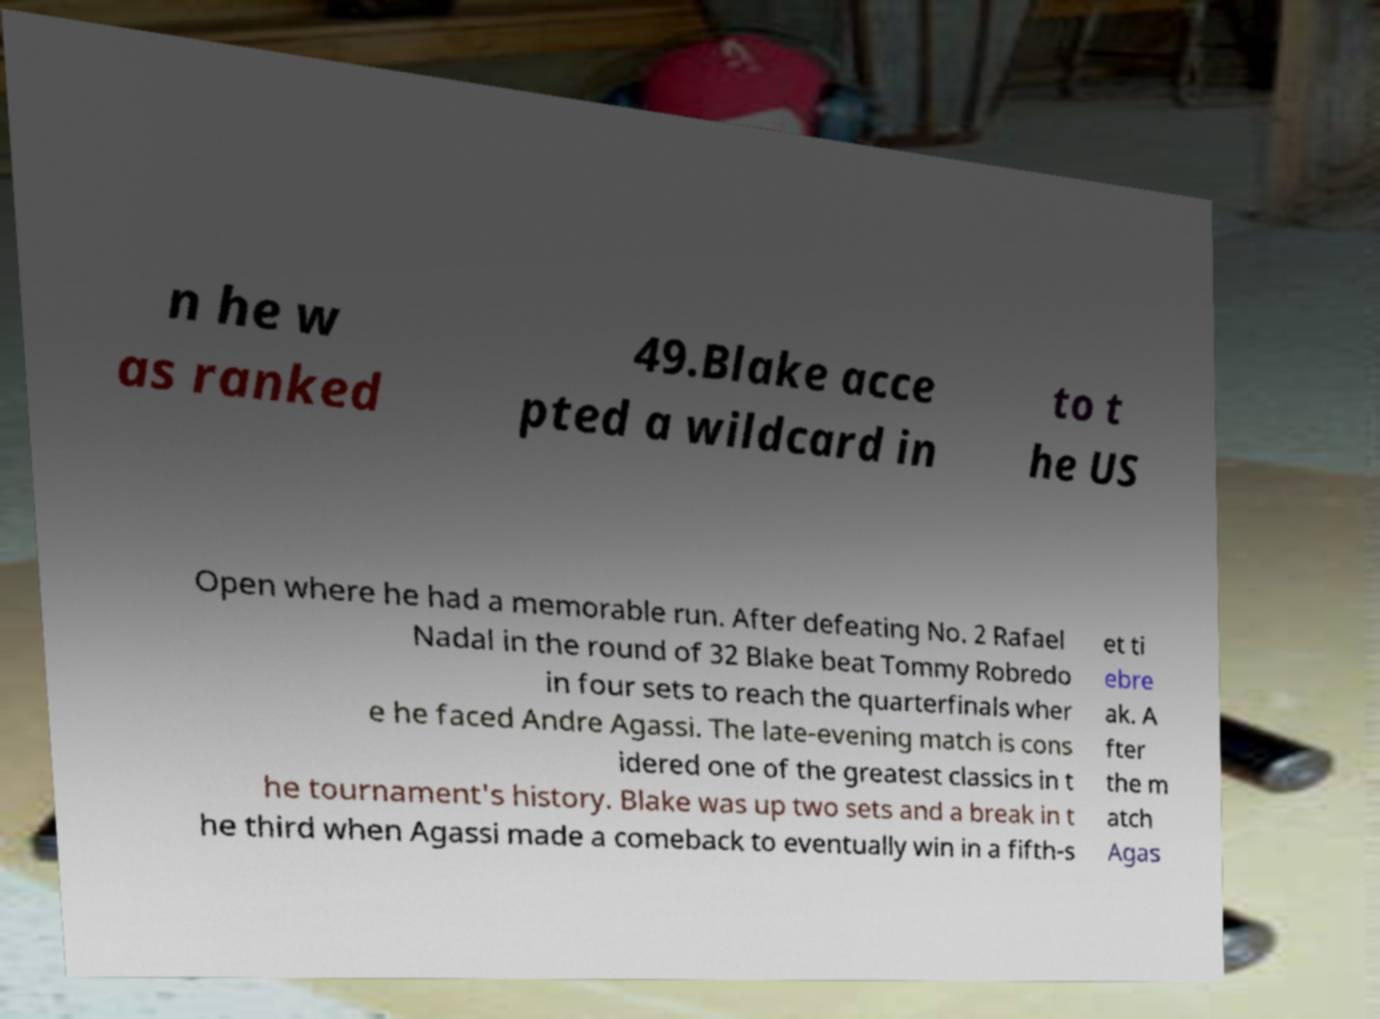What messages or text are displayed in this image? I need them in a readable, typed format. n he w as ranked 49.Blake acce pted a wildcard in to t he US Open where he had a memorable run. After defeating No. 2 Rafael Nadal in the round of 32 Blake beat Tommy Robredo in four sets to reach the quarterfinals wher e he faced Andre Agassi. The late-evening match is cons idered one of the greatest classics in t he tournament's history. Blake was up two sets and a break in t he third when Agassi made a comeback to eventually win in a fifth-s et ti ebre ak. A fter the m atch Agas 